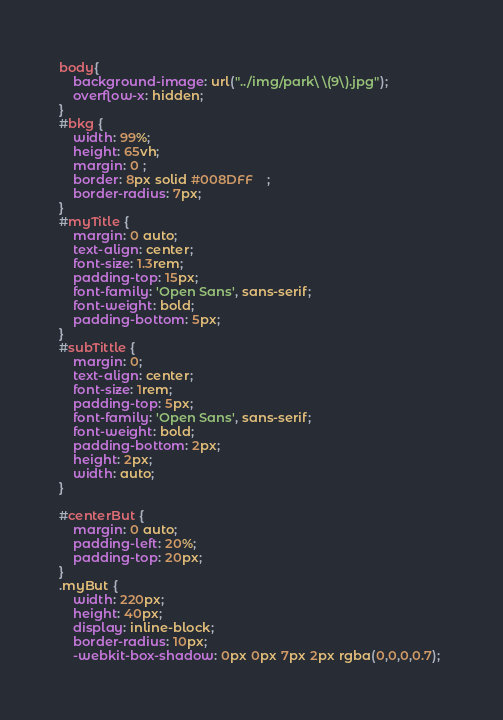<code> <loc_0><loc_0><loc_500><loc_500><_CSS_>body{
    background-image: url("../img/park\ \(9\).jpg");
    overflow-x: hidden;
}
#bkg {
    width: 99%;
    height: 65vh;
    margin: 0 ;
    border: 8px solid #008DFF    ;
    border-radius: 7px;
}
#myTitle {
    margin: 0 auto;
    text-align: center;
    font-size: 1.3rem;
    padding-top: 15px;
    font-family: 'Open Sans', sans-serif;
    font-weight: bold;
    padding-bottom: 5px;
}
#subTittle {
    margin: 0;
    text-align: center;
    font-size: 1rem;
    padding-top: 5px;
    font-family: 'Open Sans', sans-serif;
    font-weight: bold;
    padding-bottom: 2px;
    height: 2px;
    width: auto;
}

#centerBut {
    margin: 0 auto;
    padding-left: 20%;
    padding-top: 20px;
}
.myBut {
    width: 220px;
    height: 40px;
    display: inline-block;
    border-radius: 10px;
    -webkit-box-shadow: 0px 0px 7px 2px rgba(0,0,0,0.7); </code> 